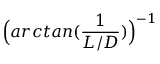<formula> <loc_0><loc_0><loc_500><loc_500>\left ( a r c t a n ( \frac { 1 } { L / D } ) \right ) ^ { - 1 }</formula> 